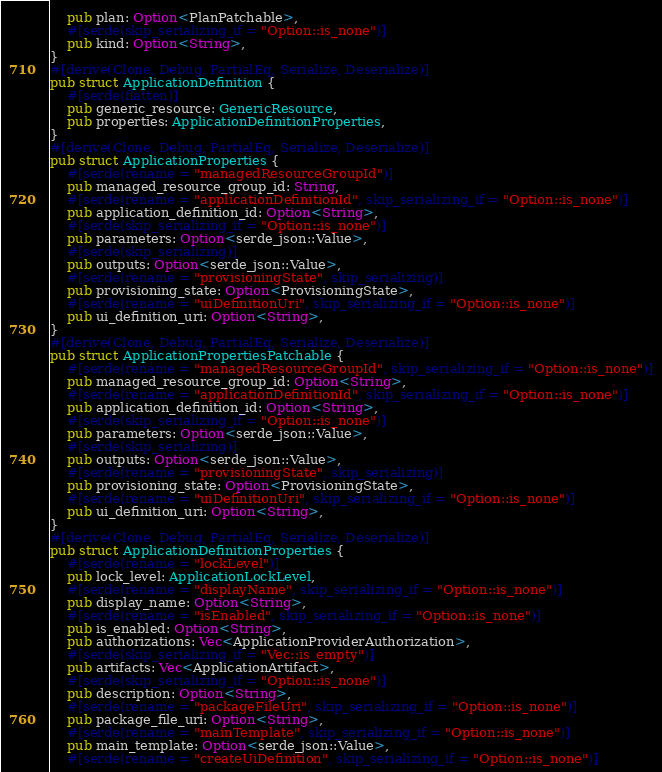<code> <loc_0><loc_0><loc_500><loc_500><_Rust_>    pub plan: Option<PlanPatchable>,
    #[serde(skip_serializing_if = "Option::is_none")]
    pub kind: Option<String>,
}
#[derive(Clone, Debug, PartialEq, Serialize, Deserialize)]
pub struct ApplicationDefinition {
    #[serde(flatten)]
    pub generic_resource: GenericResource,
    pub properties: ApplicationDefinitionProperties,
}
#[derive(Clone, Debug, PartialEq, Serialize, Deserialize)]
pub struct ApplicationProperties {
    #[serde(rename = "managedResourceGroupId")]
    pub managed_resource_group_id: String,
    #[serde(rename = "applicationDefinitionId", skip_serializing_if = "Option::is_none")]
    pub application_definition_id: Option<String>,
    #[serde(skip_serializing_if = "Option::is_none")]
    pub parameters: Option<serde_json::Value>,
    #[serde(skip_serializing)]
    pub outputs: Option<serde_json::Value>,
    #[serde(rename = "provisioningState", skip_serializing)]
    pub provisioning_state: Option<ProvisioningState>,
    #[serde(rename = "uiDefinitionUri", skip_serializing_if = "Option::is_none")]
    pub ui_definition_uri: Option<String>,
}
#[derive(Clone, Debug, PartialEq, Serialize, Deserialize)]
pub struct ApplicationPropertiesPatchable {
    #[serde(rename = "managedResourceGroupId", skip_serializing_if = "Option::is_none")]
    pub managed_resource_group_id: Option<String>,
    #[serde(rename = "applicationDefinitionId", skip_serializing_if = "Option::is_none")]
    pub application_definition_id: Option<String>,
    #[serde(skip_serializing_if = "Option::is_none")]
    pub parameters: Option<serde_json::Value>,
    #[serde(skip_serializing)]
    pub outputs: Option<serde_json::Value>,
    #[serde(rename = "provisioningState", skip_serializing)]
    pub provisioning_state: Option<ProvisioningState>,
    #[serde(rename = "uiDefinitionUri", skip_serializing_if = "Option::is_none")]
    pub ui_definition_uri: Option<String>,
}
#[derive(Clone, Debug, PartialEq, Serialize, Deserialize)]
pub struct ApplicationDefinitionProperties {
    #[serde(rename = "lockLevel")]
    pub lock_level: ApplicationLockLevel,
    #[serde(rename = "displayName", skip_serializing_if = "Option::is_none")]
    pub display_name: Option<String>,
    #[serde(rename = "isEnabled", skip_serializing_if = "Option::is_none")]
    pub is_enabled: Option<String>,
    pub authorizations: Vec<ApplicationProviderAuthorization>,
    #[serde(skip_serializing_if = "Vec::is_empty")]
    pub artifacts: Vec<ApplicationArtifact>,
    #[serde(skip_serializing_if = "Option::is_none")]
    pub description: Option<String>,
    #[serde(rename = "packageFileUri", skip_serializing_if = "Option::is_none")]
    pub package_file_uri: Option<String>,
    #[serde(rename = "mainTemplate", skip_serializing_if = "Option::is_none")]
    pub main_template: Option<serde_json::Value>,
    #[serde(rename = "createUiDefinition", skip_serializing_if = "Option::is_none")]</code> 